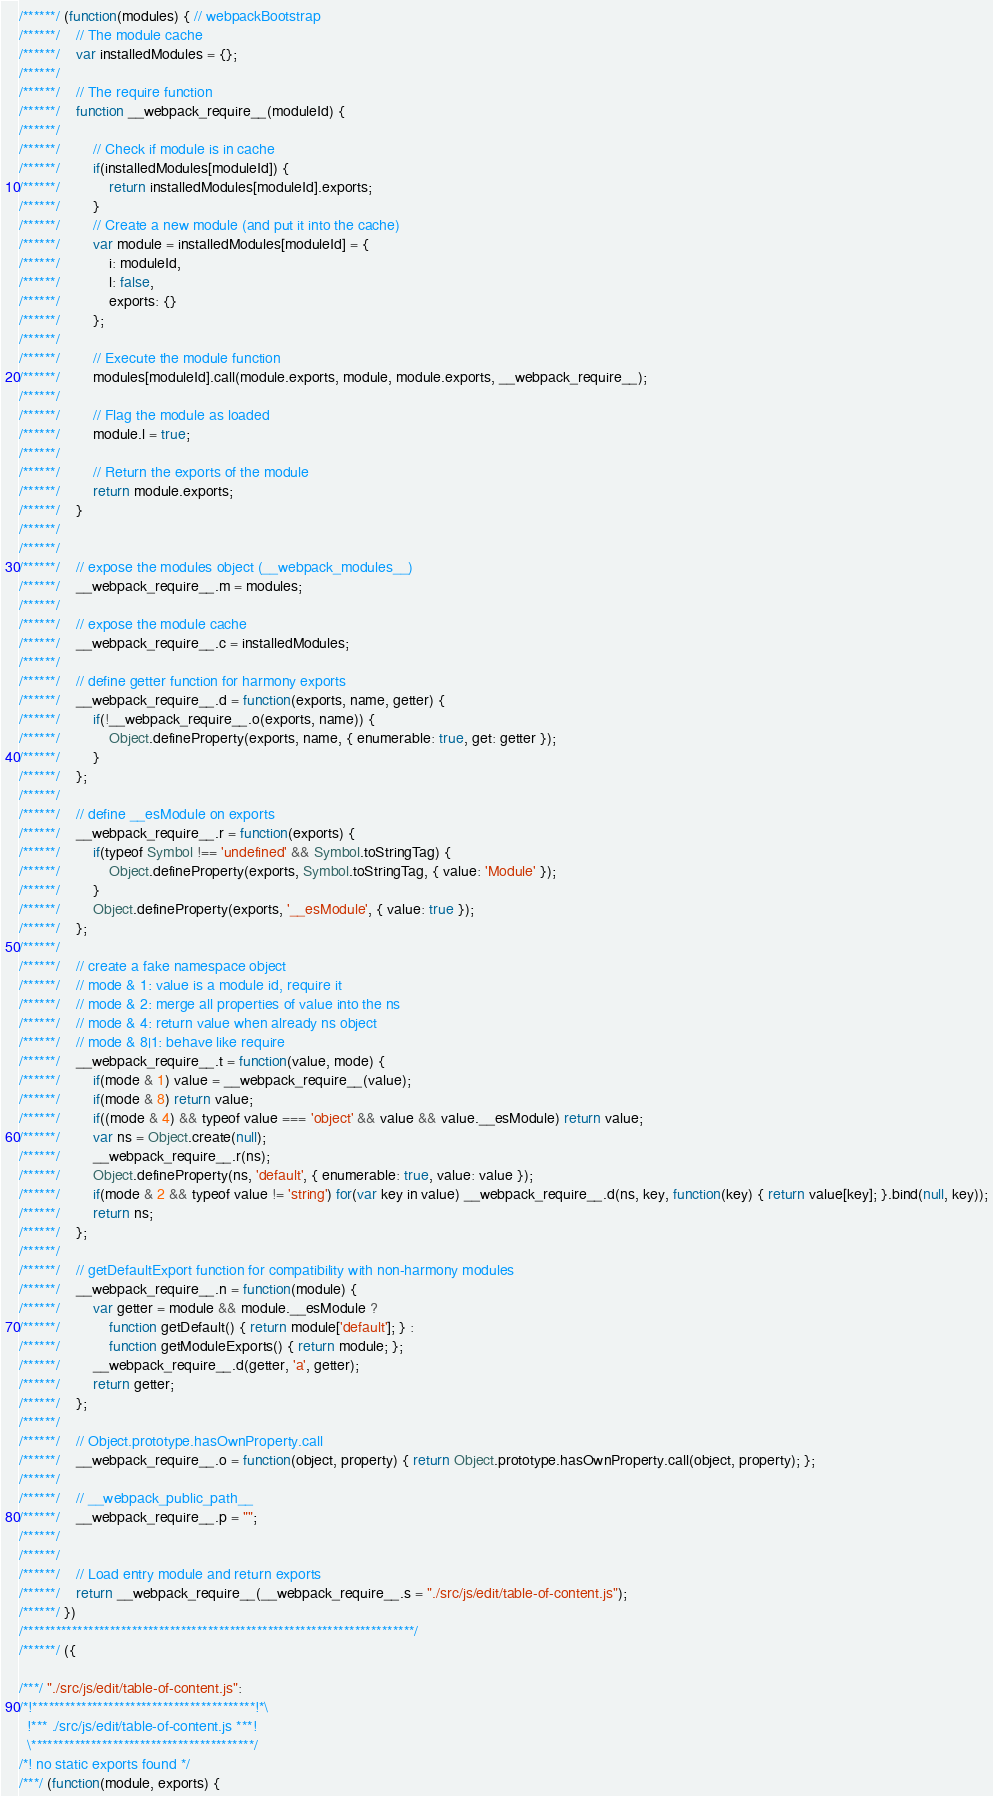Convert code to text. <code><loc_0><loc_0><loc_500><loc_500><_JavaScript_>/******/ (function(modules) { // webpackBootstrap
/******/ 	// The module cache
/******/ 	var installedModules = {};
/******/
/******/ 	// The require function
/******/ 	function __webpack_require__(moduleId) {
/******/
/******/ 		// Check if module is in cache
/******/ 		if(installedModules[moduleId]) {
/******/ 			return installedModules[moduleId].exports;
/******/ 		}
/******/ 		// Create a new module (and put it into the cache)
/******/ 		var module = installedModules[moduleId] = {
/******/ 			i: moduleId,
/******/ 			l: false,
/******/ 			exports: {}
/******/ 		};
/******/
/******/ 		// Execute the module function
/******/ 		modules[moduleId].call(module.exports, module, module.exports, __webpack_require__);
/******/
/******/ 		// Flag the module as loaded
/******/ 		module.l = true;
/******/
/******/ 		// Return the exports of the module
/******/ 		return module.exports;
/******/ 	}
/******/
/******/
/******/ 	// expose the modules object (__webpack_modules__)
/******/ 	__webpack_require__.m = modules;
/******/
/******/ 	// expose the module cache
/******/ 	__webpack_require__.c = installedModules;
/******/
/******/ 	// define getter function for harmony exports
/******/ 	__webpack_require__.d = function(exports, name, getter) {
/******/ 		if(!__webpack_require__.o(exports, name)) {
/******/ 			Object.defineProperty(exports, name, { enumerable: true, get: getter });
/******/ 		}
/******/ 	};
/******/
/******/ 	// define __esModule on exports
/******/ 	__webpack_require__.r = function(exports) {
/******/ 		if(typeof Symbol !== 'undefined' && Symbol.toStringTag) {
/******/ 			Object.defineProperty(exports, Symbol.toStringTag, { value: 'Module' });
/******/ 		}
/******/ 		Object.defineProperty(exports, '__esModule', { value: true });
/******/ 	};
/******/
/******/ 	// create a fake namespace object
/******/ 	// mode & 1: value is a module id, require it
/******/ 	// mode & 2: merge all properties of value into the ns
/******/ 	// mode & 4: return value when already ns object
/******/ 	// mode & 8|1: behave like require
/******/ 	__webpack_require__.t = function(value, mode) {
/******/ 		if(mode & 1) value = __webpack_require__(value);
/******/ 		if(mode & 8) return value;
/******/ 		if((mode & 4) && typeof value === 'object' && value && value.__esModule) return value;
/******/ 		var ns = Object.create(null);
/******/ 		__webpack_require__.r(ns);
/******/ 		Object.defineProperty(ns, 'default', { enumerable: true, value: value });
/******/ 		if(mode & 2 && typeof value != 'string') for(var key in value) __webpack_require__.d(ns, key, function(key) { return value[key]; }.bind(null, key));
/******/ 		return ns;
/******/ 	};
/******/
/******/ 	// getDefaultExport function for compatibility with non-harmony modules
/******/ 	__webpack_require__.n = function(module) {
/******/ 		var getter = module && module.__esModule ?
/******/ 			function getDefault() { return module['default']; } :
/******/ 			function getModuleExports() { return module; };
/******/ 		__webpack_require__.d(getter, 'a', getter);
/******/ 		return getter;
/******/ 	};
/******/
/******/ 	// Object.prototype.hasOwnProperty.call
/******/ 	__webpack_require__.o = function(object, property) { return Object.prototype.hasOwnProperty.call(object, property); };
/******/
/******/ 	// __webpack_public_path__
/******/ 	__webpack_require__.p = "";
/******/
/******/
/******/ 	// Load entry module and return exports
/******/ 	return __webpack_require__(__webpack_require__.s = "./src/js/edit/table-of-content.js");
/******/ })
/************************************************************************/
/******/ ({

/***/ "./src/js/edit/table-of-content.js":
/*!*****************************************!*\
  !*** ./src/js/edit/table-of-content.js ***!
  \*****************************************/
/*! no static exports found */
/***/ (function(module, exports) {
</code> 